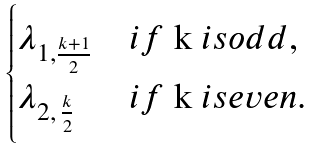Convert formula to latex. <formula><loc_0><loc_0><loc_500><loc_500>\begin{cases} \lambda _ { 1 , \frac { k + 1 } { 2 } } & i f $ k $ i s o d d , \\ \lambda _ { 2 , \, \frac { k } { 2 } } & i f $ k $ i s e v e n . \end{cases}</formula> 